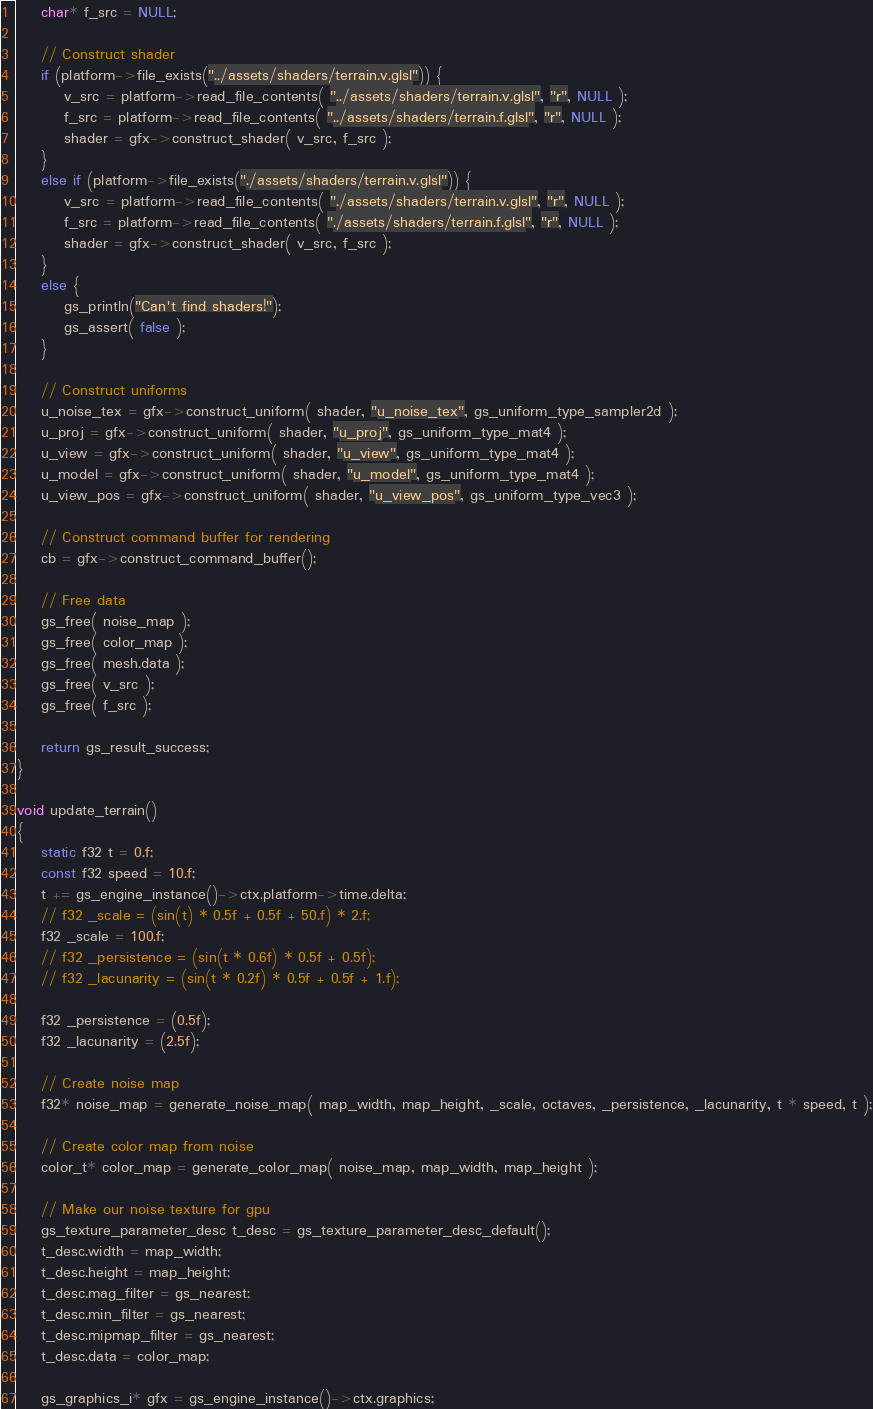<code> <loc_0><loc_0><loc_500><loc_500><_C_>	char* f_src = NULL;

	// Construct shader
	if (platform->file_exists("../assets/shaders/terrain.v.glsl")) {
		v_src = platform->read_file_contents( "../assets/shaders/terrain.v.glsl", "r", NULL );
		f_src = platform->read_file_contents( "../assets/shaders/terrain.f.glsl", "r", NULL );
		shader = gfx->construct_shader( v_src, f_src );
	}
	else if (platform->file_exists("./assets/shaders/terrain.v.glsl")) {
		v_src = platform->read_file_contents( "./assets/shaders/terrain.v.glsl", "r", NULL );
		f_src = platform->read_file_contents( "./assets/shaders/terrain.f.glsl", "r", NULL );
		shader = gfx->construct_shader( v_src, f_src );
	}
	else {
		gs_println("Can't find shaders!");
		gs_assert( false );
	}

	// Construct uniforms
	u_noise_tex = gfx->construct_uniform( shader, "u_noise_tex", gs_uniform_type_sampler2d );
	u_proj = gfx->construct_uniform( shader, "u_proj", gs_uniform_type_mat4 );
	u_view = gfx->construct_uniform( shader, "u_view", gs_uniform_type_mat4 );
	u_model = gfx->construct_uniform( shader, "u_model", gs_uniform_type_mat4 );
	u_view_pos = gfx->construct_uniform( shader, "u_view_pos", gs_uniform_type_vec3 );

	// Construct command buffer for rendering
	cb = gfx->construct_command_buffer();

	// Free data
	gs_free( noise_map );
	gs_free( color_map );
	gs_free( mesh.data );
	gs_free( v_src );
	gs_free( f_src );

	return gs_result_success;
}

void update_terrain()
{
	static f32 t = 0.f;
	const f32 speed = 10.f;
	t += gs_engine_instance()->ctx.platform->time.delta;
	// f32 _scale = (sin(t) * 0.5f + 0.5f + 50.f) * 2.f;
	f32 _scale = 100.f;
	// f32 _persistence = (sin(t * 0.6f) * 0.5f + 0.5f);
	// f32 _lacunarity = (sin(t * 0.2f) * 0.5f + 0.5f + 1.f);

	f32 _persistence = (0.5f);
	f32 _lacunarity = (2.5f);

	// Create noise map
	f32* noise_map = generate_noise_map( map_width, map_height, _scale, octaves, _persistence, _lacunarity, t * speed, t );

	// Create color map from noise
	color_t* color_map = generate_color_map( noise_map, map_width, map_height );

	// Make our noise texture for gpu
	gs_texture_parameter_desc t_desc = gs_texture_parameter_desc_default();
	t_desc.width = map_width;
	t_desc.height = map_height;
	t_desc.mag_filter = gs_nearest;
	t_desc.min_filter = gs_nearest;
	t_desc.mipmap_filter = gs_nearest;
	t_desc.data = color_map; 

	gs_graphics_i* gfx = gs_engine_instance()->ctx.graphics;
</code> 